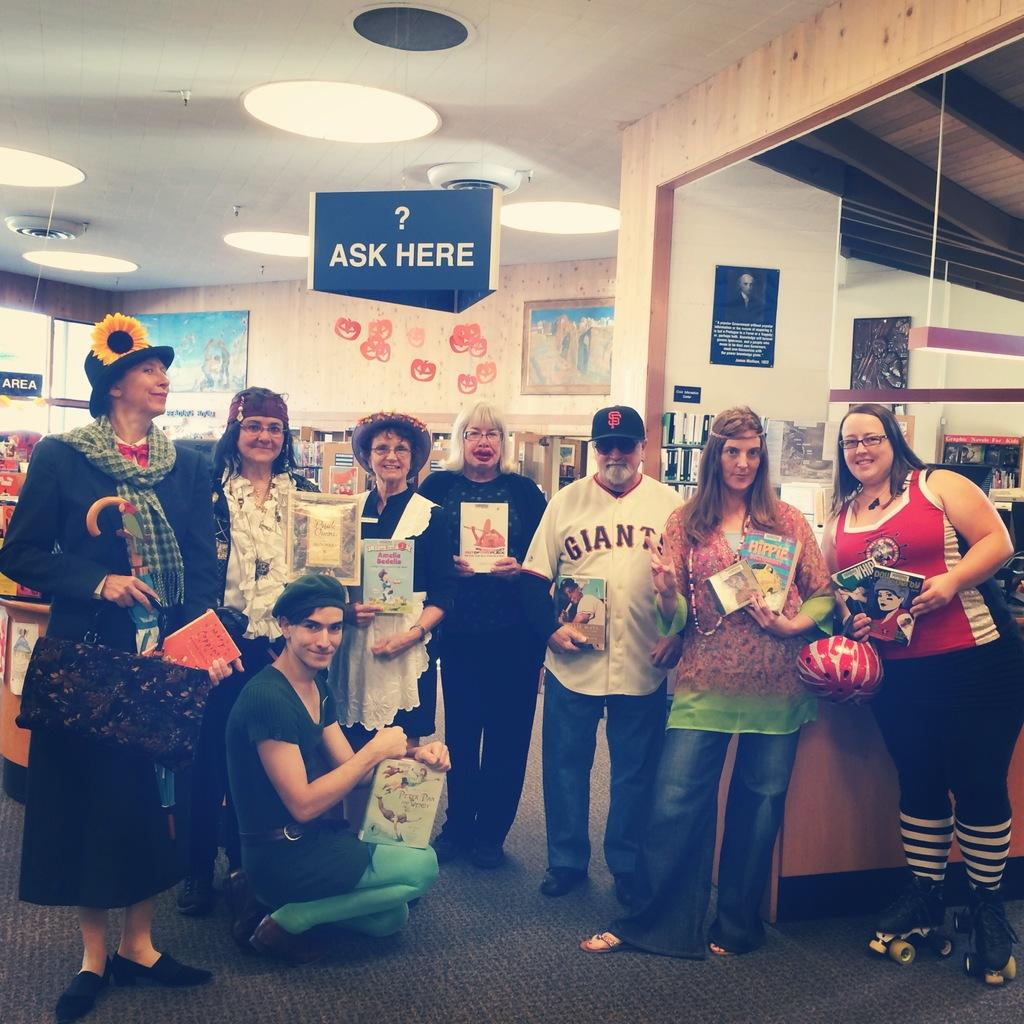<image>
Relay a brief, clear account of the picture shown. group of people holding books under blue sign that has "? ask here" on it 